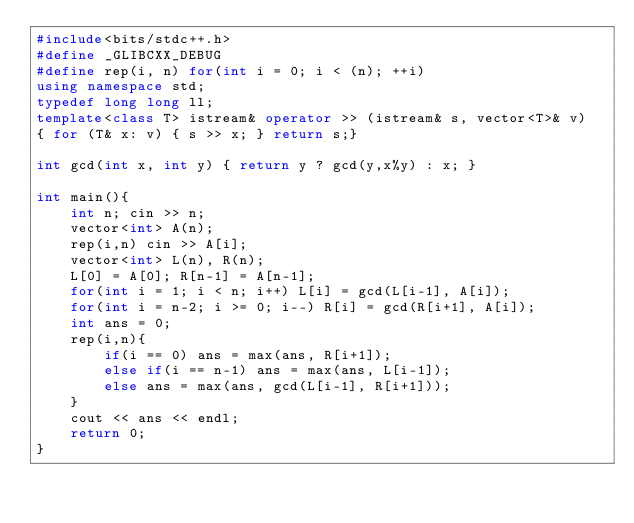Convert code to text. <code><loc_0><loc_0><loc_500><loc_500><_C++_>#include<bits/stdc++.h>
#define _GLIBCXX_DEBUG
#define rep(i, n) for(int i = 0; i < (n); ++i)
using namespace std;
typedef long long ll;
template<class T> istream& operator >> (istream& s, vector<T>& v)
{ for (T& x: v) { s >> x; } return s;}

int gcd(int x, int y) { return y ? gcd(y,x%y) : x; }

int main(){
    int n; cin >> n;
    vector<int> A(n);
    rep(i,n) cin >> A[i];
    vector<int> L(n), R(n);
    L[0] = A[0]; R[n-1] = A[n-1];
    for(int i = 1; i < n; i++) L[i] = gcd(L[i-1], A[i]);
    for(int i = n-2; i >= 0; i--) R[i] = gcd(R[i+1], A[i]);
    int ans = 0;
    rep(i,n){
        if(i == 0) ans = max(ans, R[i+1]);
        else if(i == n-1) ans = max(ans, L[i-1]);
        else ans = max(ans, gcd(L[i-1], R[i+1]));
    }
    cout << ans << endl;
    return 0;
}</code> 